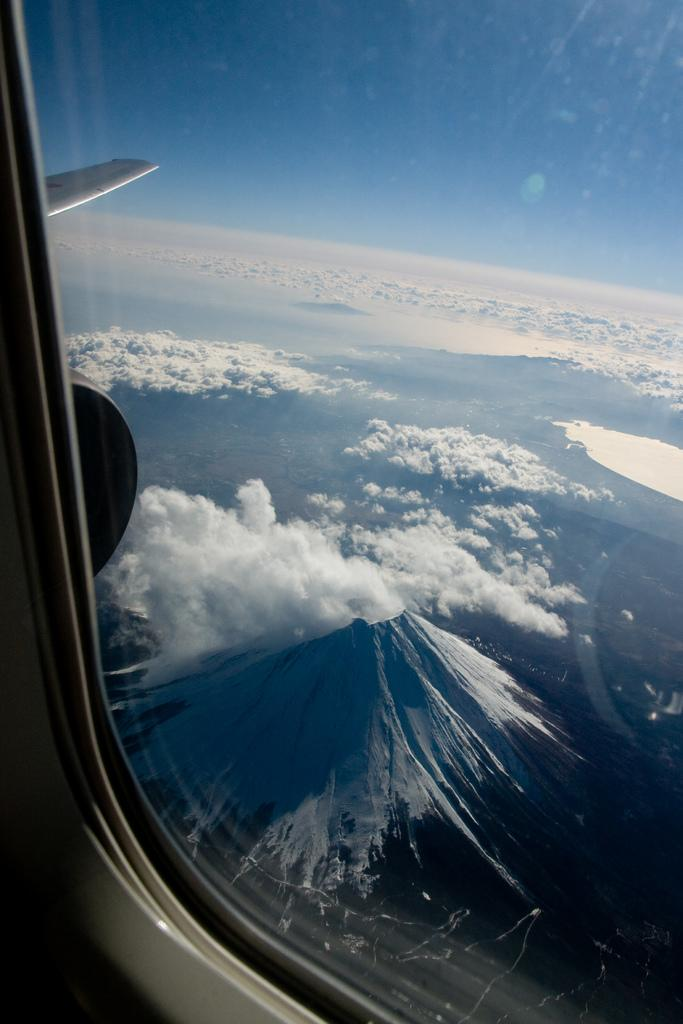What is the location of the person taking the image? The image is taken from inside an airplane. What is visible in the image that provides a view of the outside? There is a window glass in the image. What can be seen through the window glass? Clouds and the sky are visible in the outside view. What type of stone can be seen forming a pattern on the floor in the image? There is no stone or floor visible in the image; it is taken from inside an airplane and shows a view through the window glass. Can you describe the worm crawling on the window glass in the image? There is no worm present on the window glass in the image. 